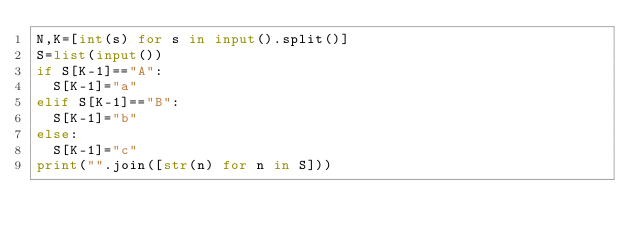<code> <loc_0><loc_0><loc_500><loc_500><_Python_>N,K=[int(s) for s in input().split()]
S=list(input())
if S[K-1]=="A":
  S[K-1]="a"
elif S[K-1]=="B":
  S[K-1]="b"
else:
  S[K-1]="c"
print("".join([str(n) for n in S]))</code> 